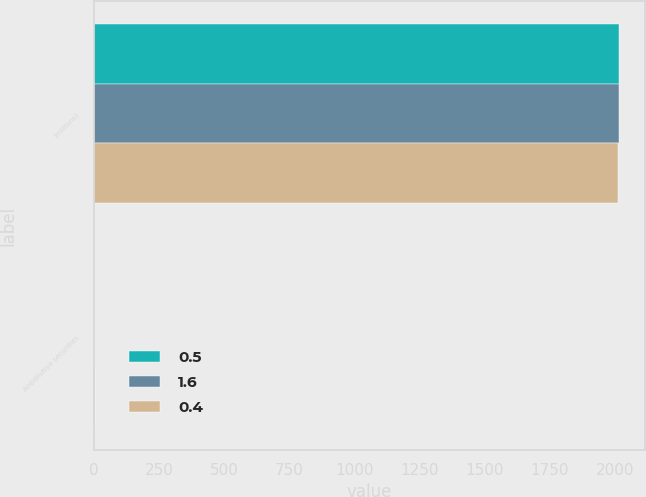Convert chart to OTSL. <chart><loc_0><loc_0><loc_500><loc_500><stacked_bar_chart><ecel><fcel>(millions)<fcel>Antidilutive securities<nl><fcel>0.5<fcel>2016<fcel>0.5<nl><fcel>1.6<fcel>2015<fcel>0.4<nl><fcel>0.4<fcel>2014<fcel>1.6<nl></chart> 